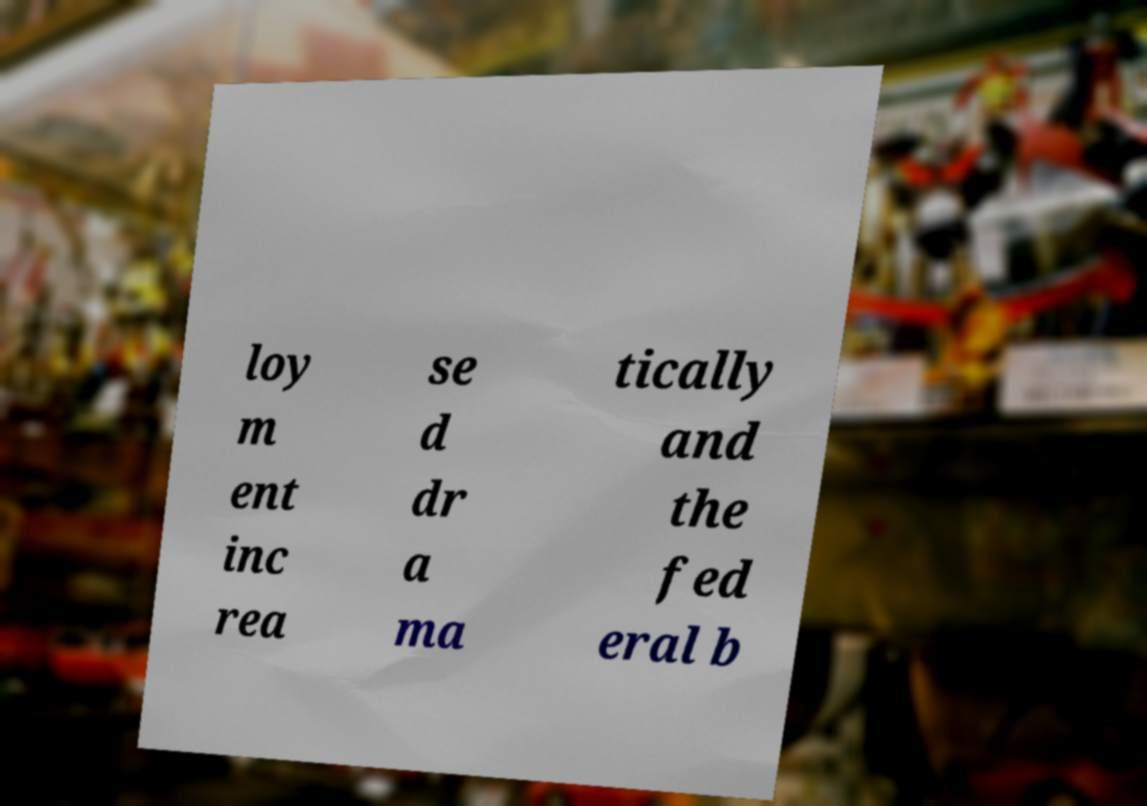Please identify and transcribe the text found in this image. loy m ent inc rea se d dr a ma tically and the fed eral b 